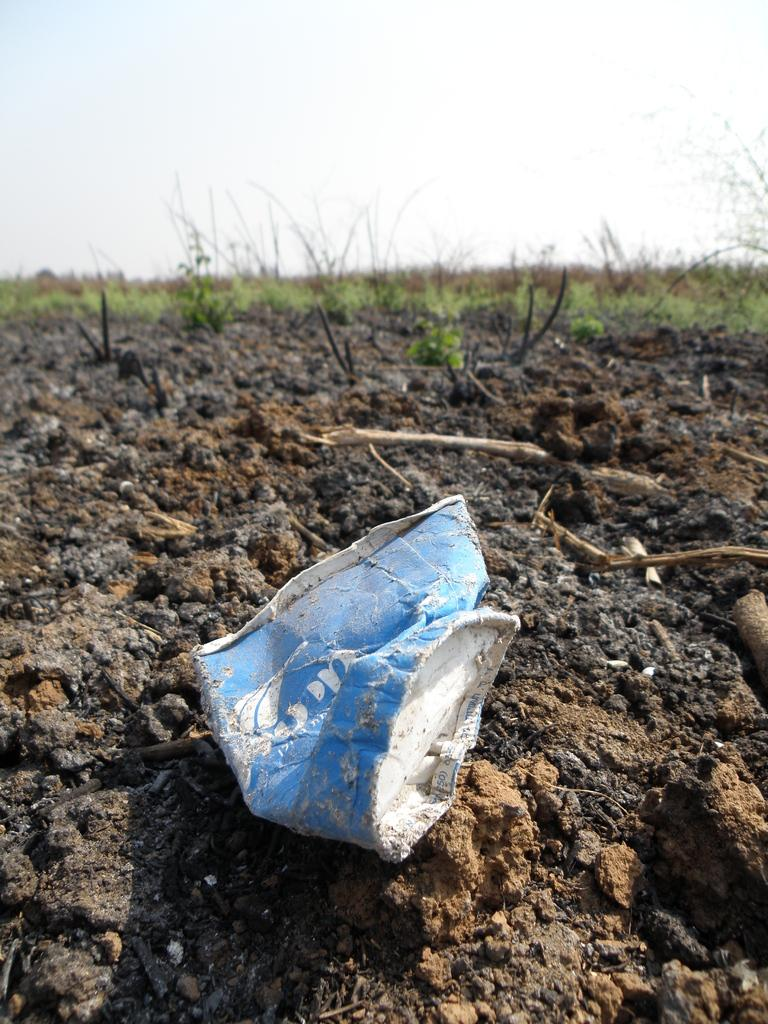What is the main object on the soil in the image? There is an object on the soil in the image, but the specific object is not mentioned in the facts. What type of vegetation can be seen in the background of the image? There is grass and plants in the background of the image. What part of the natural environment is visible in the image? The sky is visible in the background of the image. Is there a door visible in the image? There is no mention of a door in the provided facts, so it cannot be determined if a door is present in the image. 